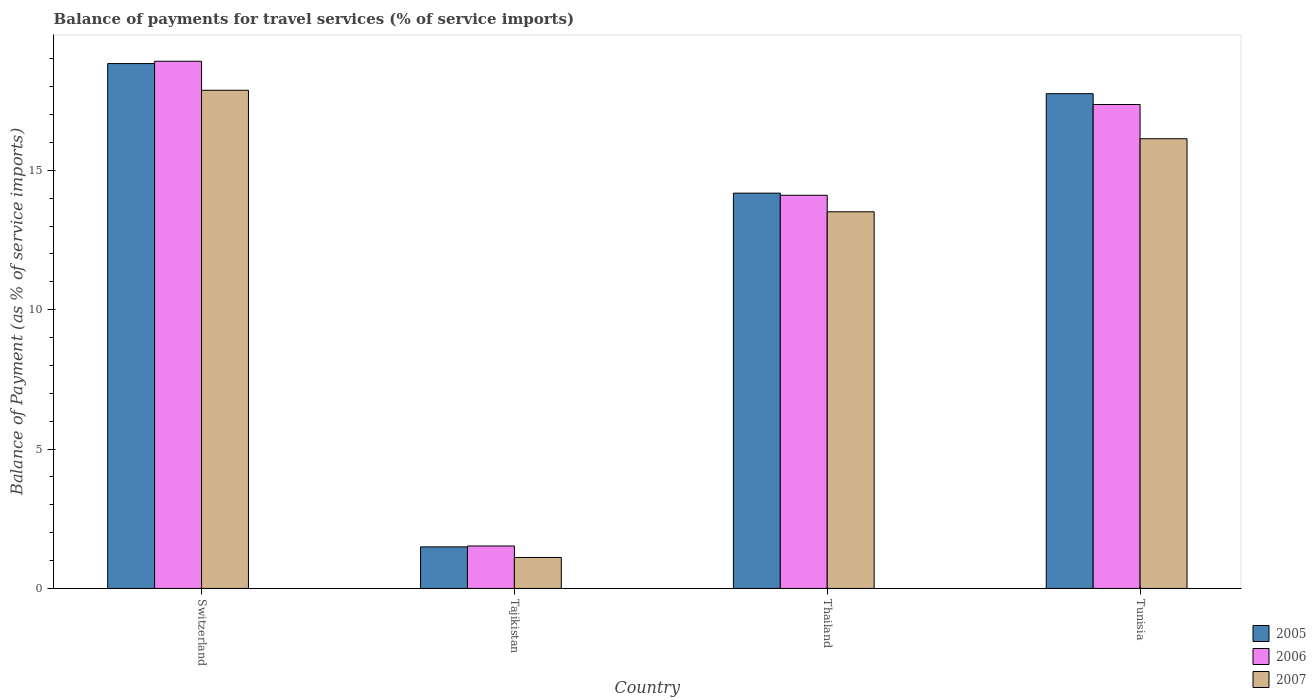How many different coloured bars are there?
Provide a short and direct response. 3. How many groups of bars are there?
Your answer should be compact. 4. Are the number of bars per tick equal to the number of legend labels?
Make the answer very short. Yes. Are the number of bars on each tick of the X-axis equal?
Your answer should be very brief. Yes. How many bars are there on the 2nd tick from the left?
Provide a short and direct response. 3. What is the label of the 4th group of bars from the left?
Make the answer very short. Tunisia. In how many cases, is the number of bars for a given country not equal to the number of legend labels?
Offer a very short reply. 0. What is the balance of payments for travel services in 2006 in Switzerland?
Provide a short and direct response. 18.91. Across all countries, what is the maximum balance of payments for travel services in 2005?
Ensure brevity in your answer.  18.83. Across all countries, what is the minimum balance of payments for travel services in 2006?
Make the answer very short. 1.52. In which country was the balance of payments for travel services in 2007 maximum?
Your answer should be very brief. Switzerland. In which country was the balance of payments for travel services in 2005 minimum?
Your response must be concise. Tajikistan. What is the total balance of payments for travel services in 2006 in the graph?
Your answer should be compact. 51.89. What is the difference between the balance of payments for travel services in 2006 in Thailand and that in Tunisia?
Offer a very short reply. -3.26. What is the difference between the balance of payments for travel services in 2006 in Switzerland and the balance of payments for travel services in 2007 in Tajikistan?
Keep it short and to the point. 17.8. What is the average balance of payments for travel services in 2005 per country?
Keep it short and to the point. 13.06. What is the difference between the balance of payments for travel services of/in 2006 and balance of payments for travel services of/in 2005 in Tajikistan?
Provide a short and direct response. 0.03. In how many countries, is the balance of payments for travel services in 2007 greater than 10 %?
Offer a terse response. 3. What is the ratio of the balance of payments for travel services in 2005 in Tajikistan to that in Thailand?
Ensure brevity in your answer.  0.11. Is the difference between the balance of payments for travel services in 2006 in Thailand and Tunisia greater than the difference between the balance of payments for travel services in 2005 in Thailand and Tunisia?
Give a very brief answer. Yes. What is the difference between the highest and the second highest balance of payments for travel services in 2007?
Your answer should be compact. -1.74. What is the difference between the highest and the lowest balance of payments for travel services in 2005?
Your answer should be compact. 17.34. In how many countries, is the balance of payments for travel services in 2007 greater than the average balance of payments for travel services in 2007 taken over all countries?
Make the answer very short. 3. What does the 3rd bar from the left in Tajikistan represents?
Your answer should be compact. 2007. How many bars are there?
Provide a short and direct response. 12. What is the difference between two consecutive major ticks on the Y-axis?
Ensure brevity in your answer.  5. Does the graph contain any zero values?
Your response must be concise. No. Does the graph contain grids?
Offer a very short reply. No. Where does the legend appear in the graph?
Offer a very short reply. Bottom right. How are the legend labels stacked?
Your answer should be very brief. Vertical. What is the title of the graph?
Your answer should be compact. Balance of payments for travel services (% of service imports). What is the label or title of the Y-axis?
Your response must be concise. Balance of Payment (as % of service imports). What is the Balance of Payment (as % of service imports) of 2005 in Switzerland?
Ensure brevity in your answer.  18.83. What is the Balance of Payment (as % of service imports) in 2006 in Switzerland?
Your response must be concise. 18.91. What is the Balance of Payment (as % of service imports) of 2007 in Switzerland?
Provide a succinct answer. 17.87. What is the Balance of Payment (as % of service imports) of 2005 in Tajikistan?
Your response must be concise. 1.49. What is the Balance of Payment (as % of service imports) of 2006 in Tajikistan?
Your answer should be compact. 1.52. What is the Balance of Payment (as % of service imports) of 2007 in Tajikistan?
Make the answer very short. 1.11. What is the Balance of Payment (as % of service imports) in 2005 in Thailand?
Provide a succinct answer. 14.18. What is the Balance of Payment (as % of service imports) in 2006 in Thailand?
Make the answer very short. 14.1. What is the Balance of Payment (as % of service imports) of 2007 in Thailand?
Offer a very short reply. 13.51. What is the Balance of Payment (as % of service imports) in 2005 in Tunisia?
Make the answer very short. 17.75. What is the Balance of Payment (as % of service imports) of 2006 in Tunisia?
Your response must be concise. 17.36. What is the Balance of Payment (as % of service imports) in 2007 in Tunisia?
Provide a short and direct response. 16.13. Across all countries, what is the maximum Balance of Payment (as % of service imports) of 2005?
Ensure brevity in your answer.  18.83. Across all countries, what is the maximum Balance of Payment (as % of service imports) of 2006?
Your response must be concise. 18.91. Across all countries, what is the maximum Balance of Payment (as % of service imports) in 2007?
Your response must be concise. 17.87. Across all countries, what is the minimum Balance of Payment (as % of service imports) in 2005?
Your answer should be very brief. 1.49. Across all countries, what is the minimum Balance of Payment (as % of service imports) in 2006?
Make the answer very short. 1.52. Across all countries, what is the minimum Balance of Payment (as % of service imports) in 2007?
Your answer should be compact. 1.11. What is the total Balance of Payment (as % of service imports) of 2005 in the graph?
Your response must be concise. 52.24. What is the total Balance of Payment (as % of service imports) of 2006 in the graph?
Offer a terse response. 51.89. What is the total Balance of Payment (as % of service imports) in 2007 in the graph?
Offer a very short reply. 48.62. What is the difference between the Balance of Payment (as % of service imports) in 2005 in Switzerland and that in Tajikistan?
Give a very brief answer. 17.34. What is the difference between the Balance of Payment (as % of service imports) of 2006 in Switzerland and that in Tajikistan?
Make the answer very short. 17.39. What is the difference between the Balance of Payment (as % of service imports) in 2007 in Switzerland and that in Tajikistan?
Offer a very short reply. 16.76. What is the difference between the Balance of Payment (as % of service imports) of 2005 in Switzerland and that in Thailand?
Provide a short and direct response. 4.65. What is the difference between the Balance of Payment (as % of service imports) in 2006 in Switzerland and that in Thailand?
Provide a succinct answer. 4.81. What is the difference between the Balance of Payment (as % of service imports) of 2007 in Switzerland and that in Thailand?
Offer a terse response. 4.36. What is the difference between the Balance of Payment (as % of service imports) of 2005 in Switzerland and that in Tunisia?
Keep it short and to the point. 1.08. What is the difference between the Balance of Payment (as % of service imports) of 2006 in Switzerland and that in Tunisia?
Your response must be concise. 1.55. What is the difference between the Balance of Payment (as % of service imports) in 2007 in Switzerland and that in Tunisia?
Offer a terse response. 1.74. What is the difference between the Balance of Payment (as % of service imports) of 2005 in Tajikistan and that in Thailand?
Your answer should be very brief. -12.69. What is the difference between the Balance of Payment (as % of service imports) in 2006 in Tajikistan and that in Thailand?
Make the answer very short. -12.58. What is the difference between the Balance of Payment (as % of service imports) of 2007 in Tajikistan and that in Thailand?
Your answer should be compact. -12.4. What is the difference between the Balance of Payment (as % of service imports) in 2005 in Tajikistan and that in Tunisia?
Keep it short and to the point. -16.26. What is the difference between the Balance of Payment (as % of service imports) of 2006 in Tajikistan and that in Tunisia?
Provide a short and direct response. -15.84. What is the difference between the Balance of Payment (as % of service imports) of 2007 in Tajikistan and that in Tunisia?
Provide a short and direct response. -15.02. What is the difference between the Balance of Payment (as % of service imports) in 2005 in Thailand and that in Tunisia?
Make the answer very short. -3.57. What is the difference between the Balance of Payment (as % of service imports) of 2006 in Thailand and that in Tunisia?
Your answer should be compact. -3.26. What is the difference between the Balance of Payment (as % of service imports) of 2007 in Thailand and that in Tunisia?
Offer a terse response. -2.62. What is the difference between the Balance of Payment (as % of service imports) in 2005 in Switzerland and the Balance of Payment (as % of service imports) in 2006 in Tajikistan?
Ensure brevity in your answer.  17.3. What is the difference between the Balance of Payment (as % of service imports) in 2005 in Switzerland and the Balance of Payment (as % of service imports) in 2007 in Tajikistan?
Ensure brevity in your answer.  17.72. What is the difference between the Balance of Payment (as % of service imports) of 2006 in Switzerland and the Balance of Payment (as % of service imports) of 2007 in Tajikistan?
Offer a terse response. 17.8. What is the difference between the Balance of Payment (as % of service imports) of 2005 in Switzerland and the Balance of Payment (as % of service imports) of 2006 in Thailand?
Your answer should be compact. 4.72. What is the difference between the Balance of Payment (as % of service imports) of 2005 in Switzerland and the Balance of Payment (as % of service imports) of 2007 in Thailand?
Provide a short and direct response. 5.32. What is the difference between the Balance of Payment (as % of service imports) in 2006 in Switzerland and the Balance of Payment (as % of service imports) in 2007 in Thailand?
Your answer should be compact. 5.4. What is the difference between the Balance of Payment (as % of service imports) of 2005 in Switzerland and the Balance of Payment (as % of service imports) of 2006 in Tunisia?
Make the answer very short. 1.47. What is the difference between the Balance of Payment (as % of service imports) in 2005 in Switzerland and the Balance of Payment (as % of service imports) in 2007 in Tunisia?
Make the answer very short. 2.7. What is the difference between the Balance of Payment (as % of service imports) of 2006 in Switzerland and the Balance of Payment (as % of service imports) of 2007 in Tunisia?
Make the answer very short. 2.78. What is the difference between the Balance of Payment (as % of service imports) in 2005 in Tajikistan and the Balance of Payment (as % of service imports) in 2006 in Thailand?
Offer a terse response. -12.61. What is the difference between the Balance of Payment (as % of service imports) of 2005 in Tajikistan and the Balance of Payment (as % of service imports) of 2007 in Thailand?
Your answer should be compact. -12.02. What is the difference between the Balance of Payment (as % of service imports) in 2006 in Tajikistan and the Balance of Payment (as % of service imports) in 2007 in Thailand?
Offer a very short reply. -11.99. What is the difference between the Balance of Payment (as % of service imports) in 2005 in Tajikistan and the Balance of Payment (as % of service imports) in 2006 in Tunisia?
Your response must be concise. -15.87. What is the difference between the Balance of Payment (as % of service imports) in 2005 in Tajikistan and the Balance of Payment (as % of service imports) in 2007 in Tunisia?
Offer a very short reply. -14.64. What is the difference between the Balance of Payment (as % of service imports) in 2006 in Tajikistan and the Balance of Payment (as % of service imports) in 2007 in Tunisia?
Provide a short and direct response. -14.61. What is the difference between the Balance of Payment (as % of service imports) of 2005 in Thailand and the Balance of Payment (as % of service imports) of 2006 in Tunisia?
Offer a terse response. -3.18. What is the difference between the Balance of Payment (as % of service imports) of 2005 in Thailand and the Balance of Payment (as % of service imports) of 2007 in Tunisia?
Ensure brevity in your answer.  -1.95. What is the difference between the Balance of Payment (as % of service imports) of 2006 in Thailand and the Balance of Payment (as % of service imports) of 2007 in Tunisia?
Your response must be concise. -2.03. What is the average Balance of Payment (as % of service imports) of 2005 per country?
Your answer should be compact. 13.06. What is the average Balance of Payment (as % of service imports) in 2006 per country?
Give a very brief answer. 12.97. What is the average Balance of Payment (as % of service imports) of 2007 per country?
Provide a succinct answer. 12.15. What is the difference between the Balance of Payment (as % of service imports) in 2005 and Balance of Payment (as % of service imports) in 2006 in Switzerland?
Keep it short and to the point. -0.08. What is the difference between the Balance of Payment (as % of service imports) of 2005 and Balance of Payment (as % of service imports) of 2007 in Switzerland?
Give a very brief answer. 0.96. What is the difference between the Balance of Payment (as % of service imports) of 2006 and Balance of Payment (as % of service imports) of 2007 in Switzerland?
Keep it short and to the point. 1.04. What is the difference between the Balance of Payment (as % of service imports) of 2005 and Balance of Payment (as % of service imports) of 2006 in Tajikistan?
Provide a short and direct response. -0.03. What is the difference between the Balance of Payment (as % of service imports) in 2005 and Balance of Payment (as % of service imports) in 2007 in Tajikistan?
Ensure brevity in your answer.  0.38. What is the difference between the Balance of Payment (as % of service imports) of 2006 and Balance of Payment (as % of service imports) of 2007 in Tajikistan?
Provide a short and direct response. 0.41. What is the difference between the Balance of Payment (as % of service imports) in 2005 and Balance of Payment (as % of service imports) in 2006 in Thailand?
Your answer should be compact. 0.08. What is the difference between the Balance of Payment (as % of service imports) of 2005 and Balance of Payment (as % of service imports) of 2007 in Thailand?
Make the answer very short. 0.67. What is the difference between the Balance of Payment (as % of service imports) in 2006 and Balance of Payment (as % of service imports) in 2007 in Thailand?
Your answer should be very brief. 0.59. What is the difference between the Balance of Payment (as % of service imports) of 2005 and Balance of Payment (as % of service imports) of 2006 in Tunisia?
Your response must be concise. 0.39. What is the difference between the Balance of Payment (as % of service imports) of 2005 and Balance of Payment (as % of service imports) of 2007 in Tunisia?
Your answer should be compact. 1.62. What is the difference between the Balance of Payment (as % of service imports) of 2006 and Balance of Payment (as % of service imports) of 2007 in Tunisia?
Provide a short and direct response. 1.23. What is the ratio of the Balance of Payment (as % of service imports) of 2005 in Switzerland to that in Tajikistan?
Your answer should be very brief. 12.63. What is the ratio of the Balance of Payment (as % of service imports) of 2006 in Switzerland to that in Tajikistan?
Keep it short and to the point. 12.42. What is the ratio of the Balance of Payment (as % of service imports) in 2007 in Switzerland to that in Tajikistan?
Your response must be concise. 16.09. What is the ratio of the Balance of Payment (as % of service imports) in 2005 in Switzerland to that in Thailand?
Offer a terse response. 1.33. What is the ratio of the Balance of Payment (as % of service imports) of 2006 in Switzerland to that in Thailand?
Your answer should be very brief. 1.34. What is the ratio of the Balance of Payment (as % of service imports) of 2007 in Switzerland to that in Thailand?
Offer a terse response. 1.32. What is the ratio of the Balance of Payment (as % of service imports) in 2005 in Switzerland to that in Tunisia?
Ensure brevity in your answer.  1.06. What is the ratio of the Balance of Payment (as % of service imports) of 2006 in Switzerland to that in Tunisia?
Give a very brief answer. 1.09. What is the ratio of the Balance of Payment (as % of service imports) in 2007 in Switzerland to that in Tunisia?
Keep it short and to the point. 1.11. What is the ratio of the Balance of Payment (as % of service imports) in 2005 in Tajikistan to that in Thailand?
Ensure brevity in your answer.  0.11. What is the ratio of the Balance of Payment (as % of service imports) of 2006 in Tajikistan to that in Thailand?
Your answer should be compact. 0.11. What is the ratio of the Balance of Payment (as % of service imports) of 2007 in Tajikistan to that in Thailand?
Keep it short and to the point. 0.08. What is the ratio of the Balance of Payment (as % of service imports) in 2005 in Tajikistan to that in Tunisia?
Give a very brief answer. 0.08. What is the ratio of the Balance of Payment (as % of service imports) of 2006 in Tajikistan to that in Tunisia?
Your answer should be compact. 0.09. What is the ratio of the Balance of Payment (as % of service imports) of 2007 in Tajikistan to that in Tunisia?
Your answer should be very brief. 0.07. What is the ratio of the Balance of Payment (as % of service imports) of 2005 in Thailand to that in Tunisia?
Give a very brief answer. 0.8. What is the ratio of the Balance of Payment (as % of service imports) of 2006 in Thailand to that in Tunisia?
Make the answer very short. 0.81. What is the ratio of the Balance of Payment (as % of service imports) in 2007 in Thailand to that in Tunisia?
Make the answer very short. 0.84. What is the difference between the highest and the second highest Balance of Payment (as % of service imports) of 2005?
Your response must be concise. 1.08. What is the difference between the highest and the second highest Balance of Payment (as % of service imports) in 2006?
Give a very brief answer. 1.55. What is the difference between the highest and the second highest Balance of Payment (as % of service imports) of 2007?
Give a very brief answer. 1.74. What is the difference between the highest and the lowest Balance of Payment (as % of service imports) in 2005?
Provide a short and direct response. 17.34. What is the difference between the highest and the lowest Balance of Payment (as % of service imports) in 2006?
Give a very brief answer. 17.39. What is the difference between the highest and the lowest Balance of Payment (as % of service imports) of 2007?
Your answer should be very brief. 16.76. 